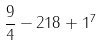Convert formula to latex. <formula><loc_0><loc_0><loc_500><loc_500>\frac { 9 } { 4 } - 2 1 8 + 1 ^ { 7 }</formula> 